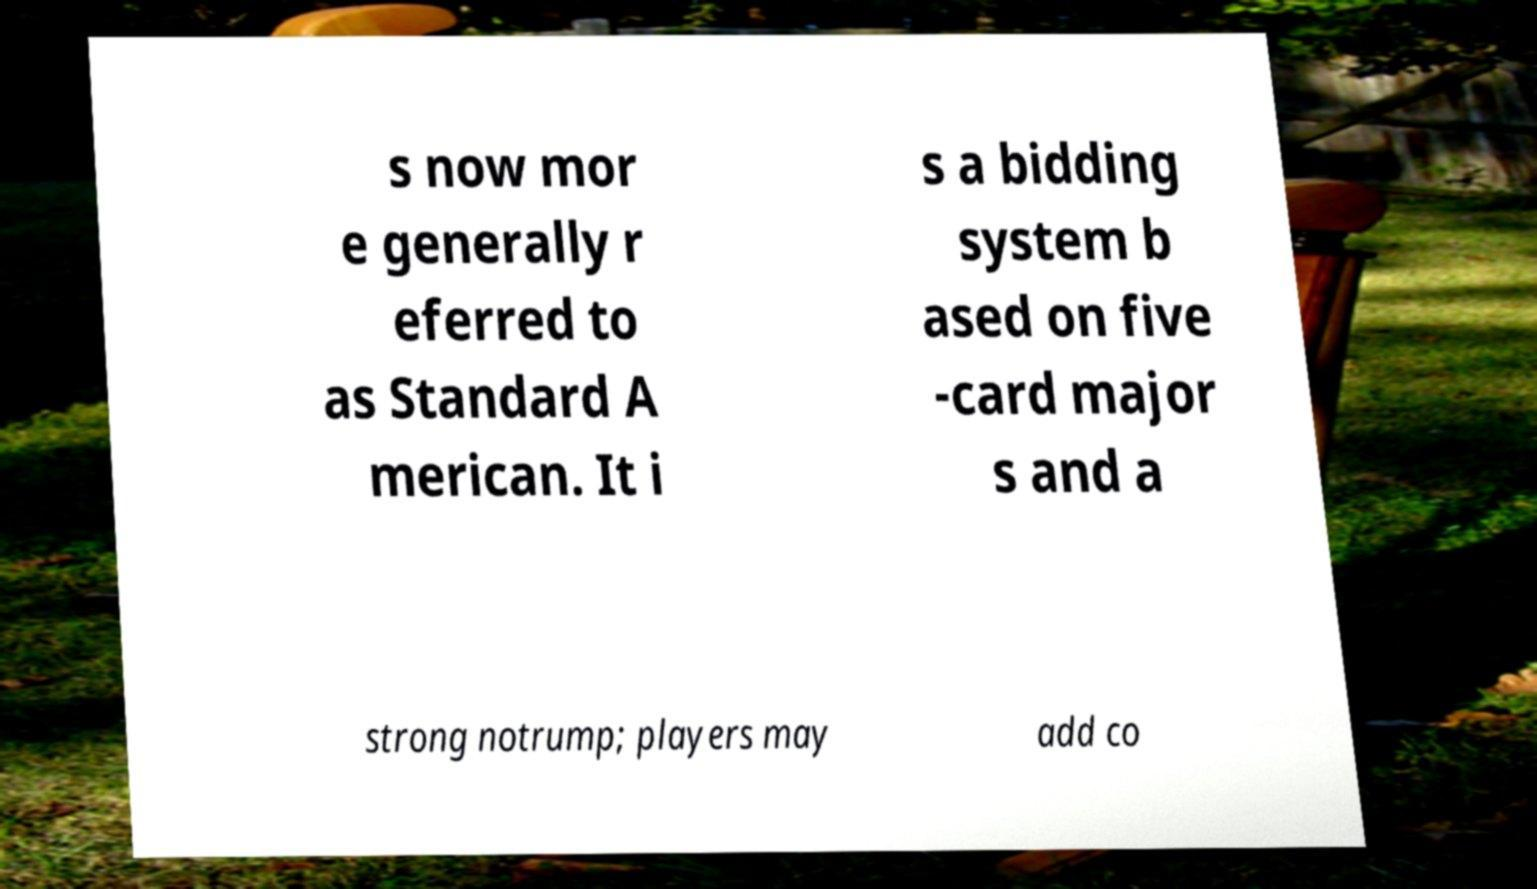Could you assist in decoding the text presented in this image and type it out clearly? s now mor e generally r eferred to as Standard A merican. It i s a bidding system b ased on five -card major s and a strong notrump; players may add co 